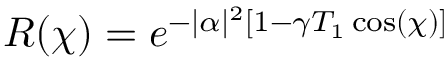Convert formula to latex. <formula><loc_0><loc_0><loc_500><loc_500>R ( \chi ) = e ^ { - | \alpha | ^ { 2 } [ 1 - \gamma T _ { 1 } \cos ( \chi ) ] }</formula> 